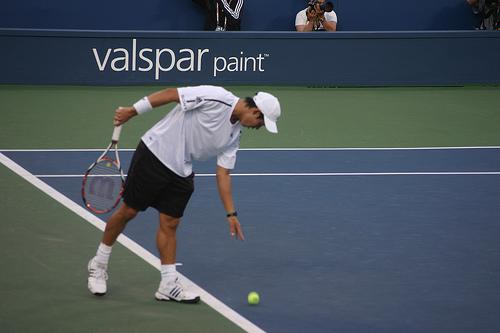Question: what sport is this?
Choices:
A. Squash.
B. Tennis.
C. Baseball.
D. Catch.
Answer with the letter. Answer: B Question: what color is the ball?
Choices:
A. Green.
B. Blue.
C. Red.
D. Yellow.
Answer with the letter. Answer: A Question: who is this?
Choices:
A. An athlete.
B. A participant.
C. A contestant.
D. Player.
Answer with the letter. Answer: D Question: how is the man?
Choices:
A. Stretching.
B. Bending.
C. Leaning.
D. Folded.
Answer with the letter. Answer: B Question: where is this scene?
Choices:
A. Ice rink.
B. Skate park.
C. On the track.
D. At a tennis court.
Answer with the letter. Answer: D 